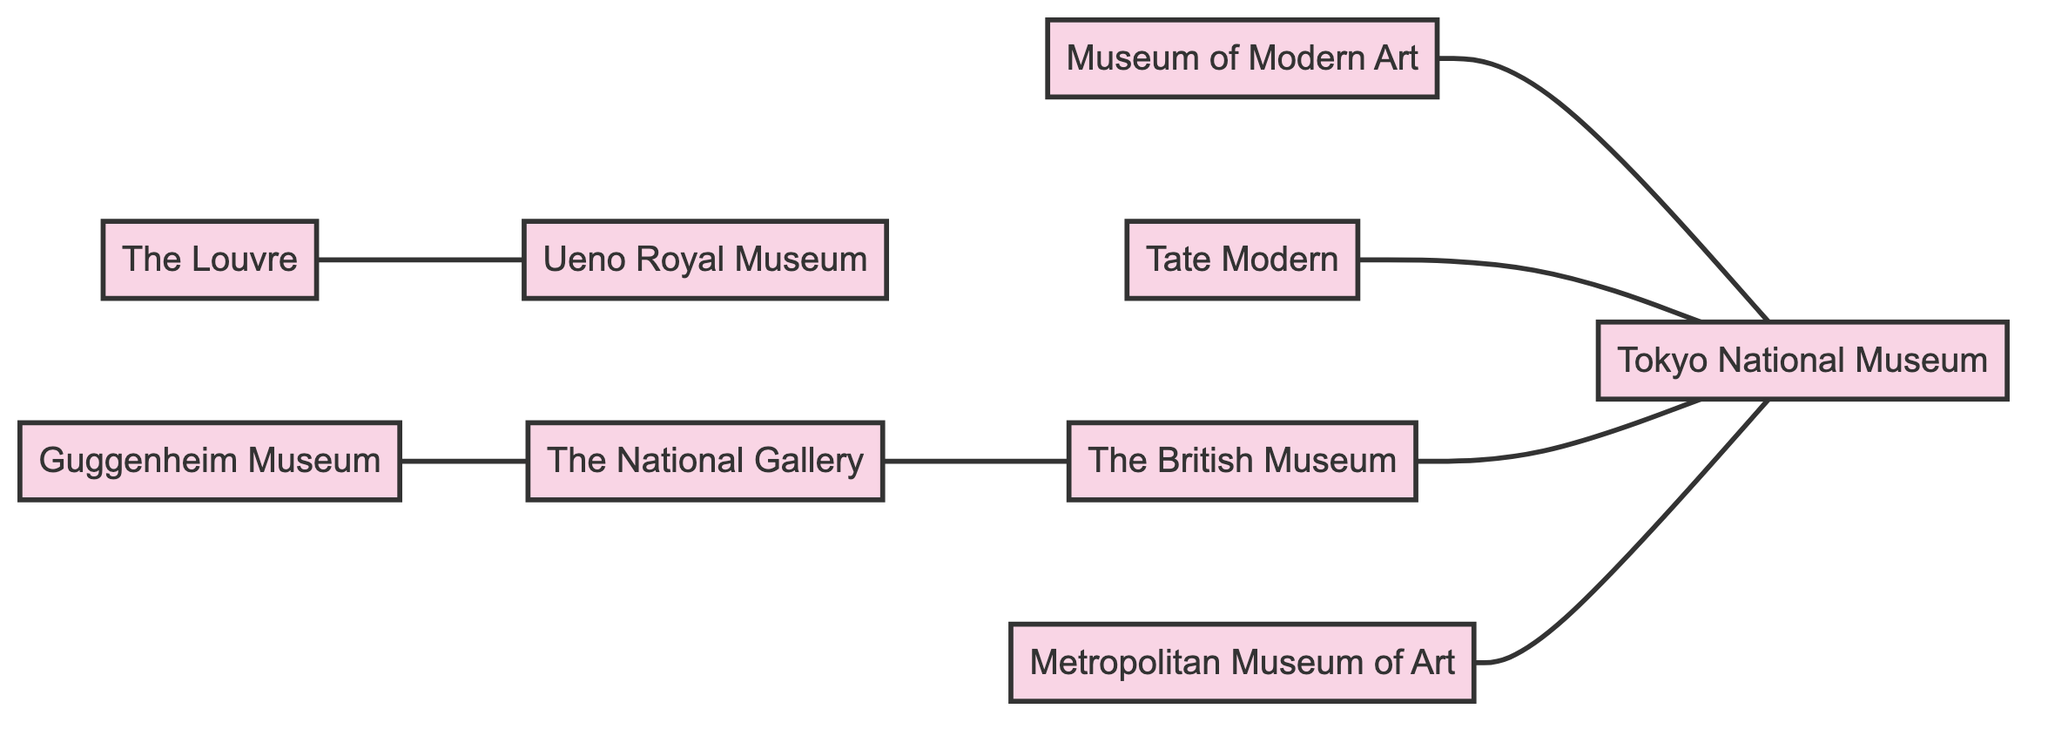What is the total number of galleries depicted in the diagram? The diagram lists 9 nodes representing different art galleries. By counting each of the nodes, we see that there are a total of 9 galleries included in the diagram.
Answer: 9 Which museum has an exhibits collaboration with the Tokyo National Museum? The diagram shows an edge labeled "Exhibits collaboration" connecting MoMA to Tokyo National Museum. This indicates that MoMA collaborates with Tokyo National Museum for exhibitions.
Answer: Museum of Modern Art What type of relationship exists between the British Museum and the Tokyo National Museum? The diagram specifies a "Japanese art focus" edge that connects the British Museum to the Tokyo National Museum. This indicates that their relationship centers on Japanese art, highlighting a specialization in exhibitions focused on that theme.
Answer: Japanese art focus How many edges are connected to the Tokyo National Museum? By examining the edges associated with the Tokyo National Museum in the diagram, we identify a total of 5 edges that connect it to other museums, indicating many collaborative relationships focused on Japanese art.
Answer: 5 Which two museums have a collaborative project relationship? The diagram shows an edge labeled "Collaborative projects" directly linking the British Museum to the National Gallery. This reveals that these two museums have initiatives that involve cooperation or joint efforts.
Answer: The British Museum and The National Gallery Which museums collaborate in joint exhibitions with Tokyo National Museum? The diagram indicates that three museums—British Museum, MoMA, and Metropolitan Museum—are connected to Tokyo National Museum by edges labeled "Japanese art focus" and "Joint exhibitions". This indicates a collaborative relationship focused on jointly curated exhibitions.
Answer: 3 What type of relationship links the Guggenheim Museum and The National Gallery? The diagram includes an edge between Guggenheim and National Gallery labeled "Co-curated events". This signifies that the two museums collaborate on events where they co-curate exhibitions or projects together.
Answer: Co-curated events Which museum is not connected to the Tokyo National Museum? Upon reviewing the edges, we see that Tate Modern is connected to Tokyo National Museum, while Ueno Royal Museum is connected to The Louvre, without any direct edge to Tokyo National Museum. Therefore, the museum that does not connect directly to Tokyo National Museum is the Ueno Royal Museum.
Answer: Ueno Royal Museum How many edges connect the Metropolitan Museum to any other gallery? The diagram shows one edge connecting the Metropolitan Museum to the Tokyo National Museum, labeled "Joint exhibitions". Therefore, the Metropolitan Museum has only one direct connection to another gallery within the diagram.
Answer: 1 